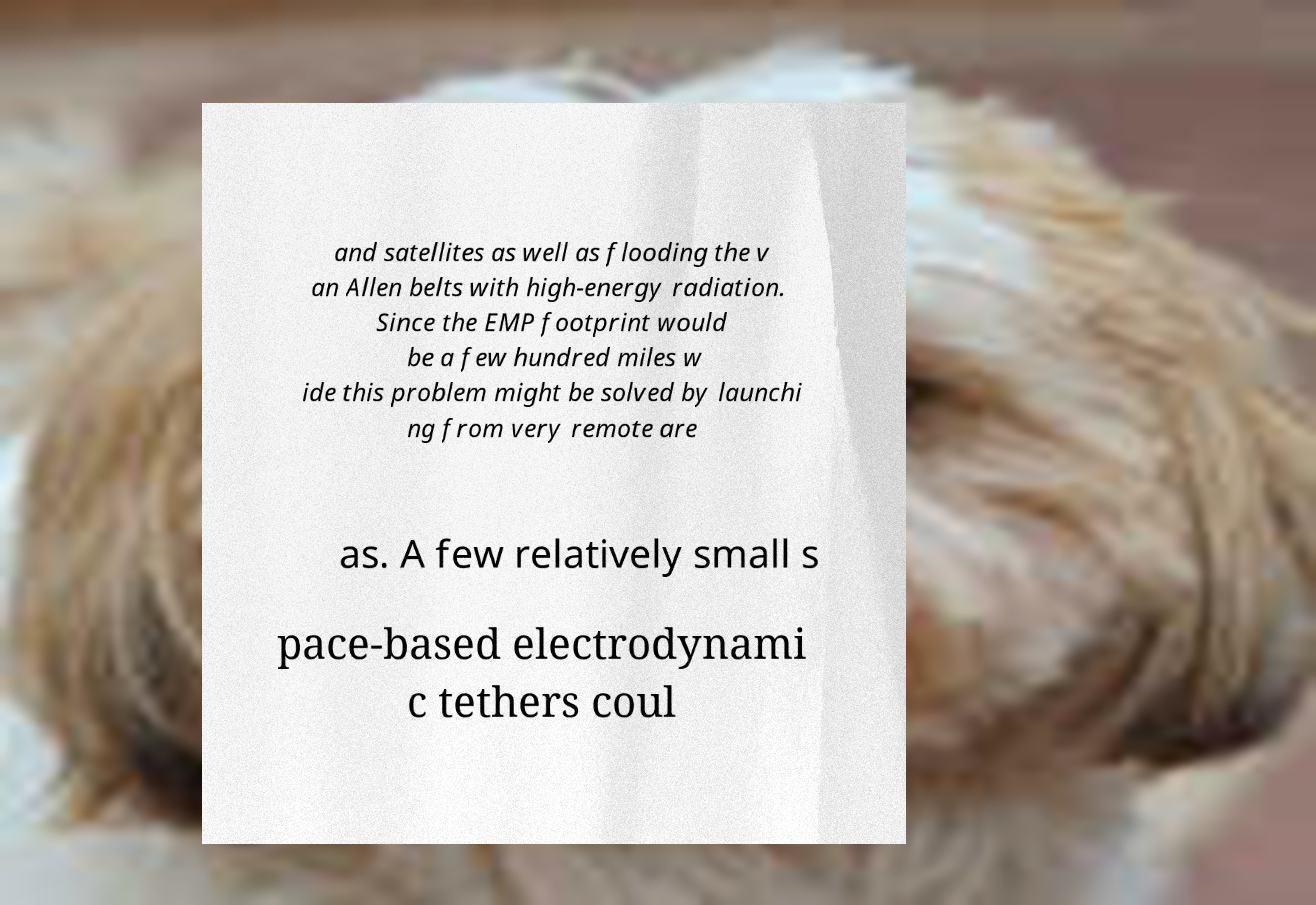I need the written content from this picture converted into text. Can you do that? and satellites as well as flooding the v an Allen belts with high-energy radiation. Since the EMP footprint would be a few hundred miles w ide this problem might be solved by launchi ng from very remote are as. A few relatively small s pace-based electrodynami c tethers coul 